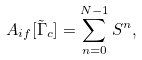<formula> <loc_0><loc_0><loc_500><loc_500>A _ { i f } [ \tilde { \Gamma } _ { c } ] = \sum _ { n = 0 } ^ { N - 1 } S ^ { n } ,</formula> 